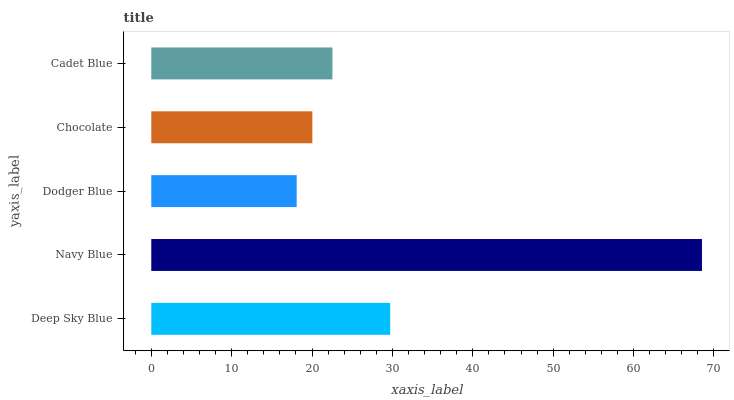Is Dodger Blue the minimum?
Answer yes or no. Yes. Is Navy Blue the maximum?
Answer yes or no. Yes. Is Navy Blue the minimum?
Answer yes or no. No. Is Dodger Blue the maximum?
Answer yes or no. No. Is Navy Blue greater than Dodger Blue?
Answer yes or no. Yes. Is Dodger Blue less than Navy Blue?
Answer yes or no. Yes. Is Dodger Blue greater than Navy Blue?
Answer yes or no. No. Is Navy Blue less than Dodger Blue?
Answer yes or no. No. Is Cadet Blue the high median?
Answer yes or no. Yes. Is Cadet Blue the low median?
Answer yes or no. Yes. Is Deep Sky Blue the high median?
Answer yes or no. No. Is Dodger Blue the low median?
Answer yes or no. No. 